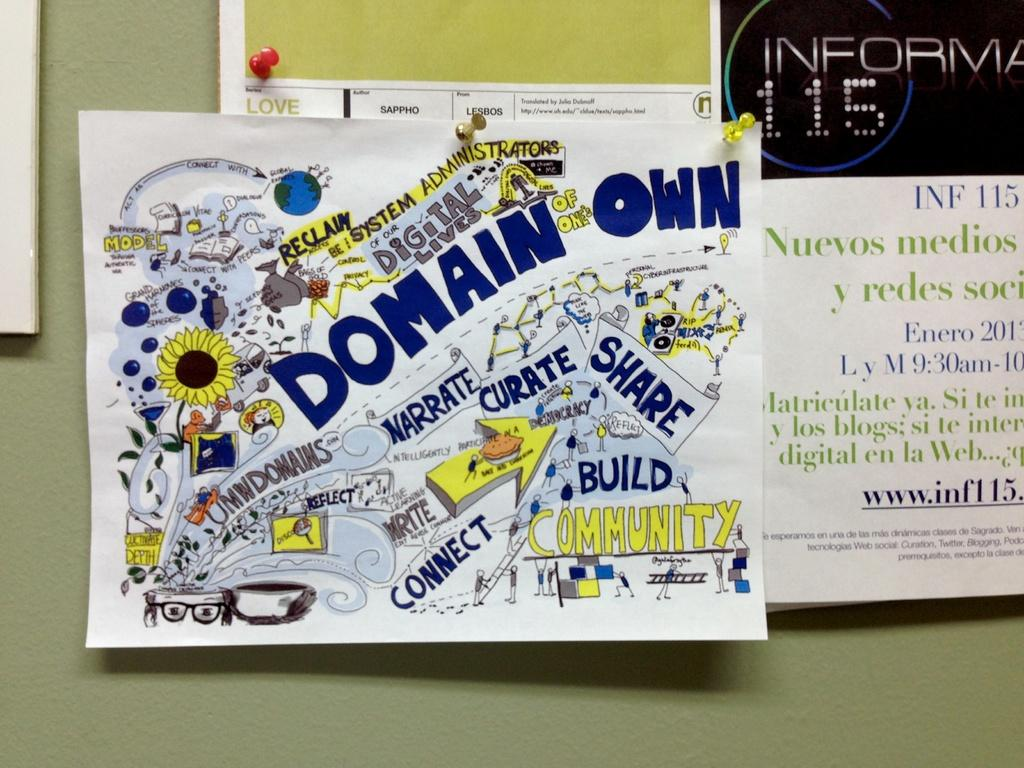Provide a one-sentence caption for the provided image. Bulletin board fliers advertise the importance of community and digital lives. 